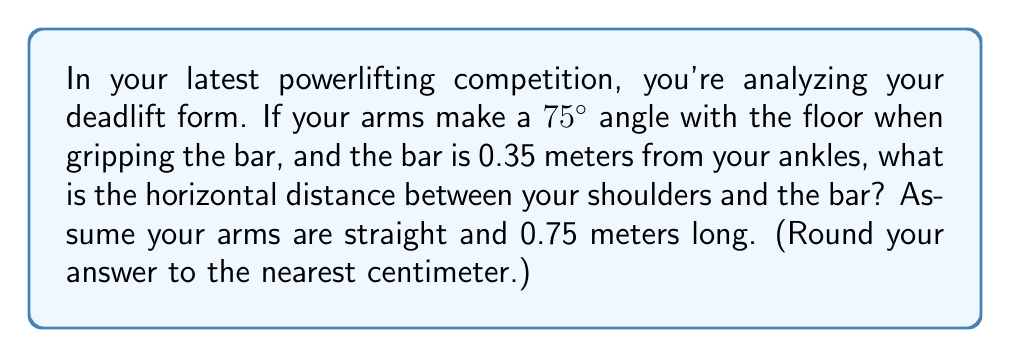Provide a solution to this math problem. Let's break this down step-by-step using trigonometry:

1) First, let's visualize the problem. We have a right triangle formed by:
   - The bar to ankle distance (vertical)
   - The horizontal distance we're looking for
   - Your arm (hypotenuse)

2) We know:
   - The angle between your arm and the floor is 75°
   - Your arm length is 0.75 meters
   - The bar is 0.35 meters from your ankles

3) We need to find the adjacent side of this triangle. We can use the cosine function:

   $$\cos \theta = \frac{\text{adjacent}}{\text{hypotenuse}}$$

4) Rearranging this, we get:

   $$\text{adjacent} = \text{hypotenuse} \times \cos \theta$$

5) Plugging in our values:

   $$\text{horizontal distance} = 0.75 \times \cos 75°$$

6) Using a calculator (or trigonometric tables):

   $$\text{horizontal distance} = 0.75 \times 0.2588 = 0.1941 \text{ meters}$$

7) Converting to centimeters and rounding to the nearest cm:

   $$0.1941 \text{ meters} = 19.41 \text{ cm} \approx 19 \text{ cm}$$
Answer: 19 cm 